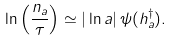<formula> <loc_0><loc_0><loc_500><loc_500>\ln \left ( \frac { n _ { a } } { \tau } \right ) \simeq | \ln a | \, \psi ( h ^ { \dag } _ { a } ) .</formula> 